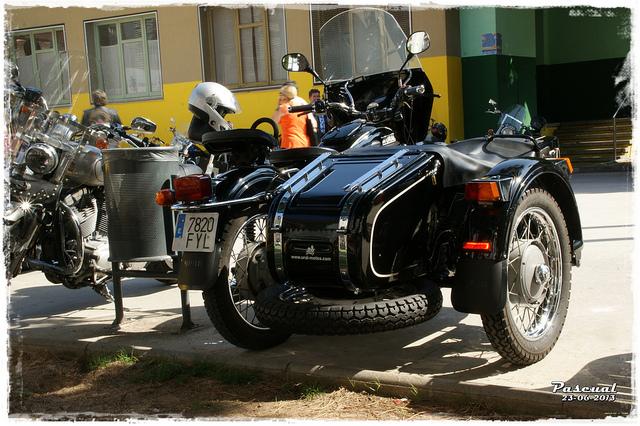What is the license plate on the first motorcycle?
Quick response, please. 7820fyl. Is there an extra tire on the motorcycle?
Concise answer only. Yes. What is attached to the black motorcycle?
Quick response, please. Sidecar. 